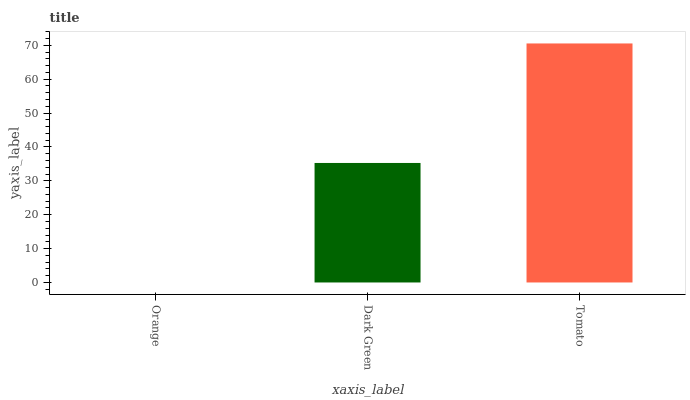Is Orange the minimum?
Answer yes or no. Yes. Is Tomato the maximum?
Answer yes or no. Yes. Is Dark Green the minimum?
Answer yes or no. No. Is Dark Green the maximum?
Answer yes or no. No. Is Dark Green greater than Orange?
Answer yes or no. Yes. Is Orange less than Dark Green?
Answer yes or no. Yes. Is Orange greater than Dark Green?
Answer yes or no. No. Is Dark Green less than Orange?
Answer yes or no. No. Is Dark Green the high median?
Answer yes or no. Yes. Is Dark Green the low median?
Answer yes or no. Yes. Is Orange the high median?
Answer yes or no. No. Is Orange the low median?
Answer yes or no. No. 